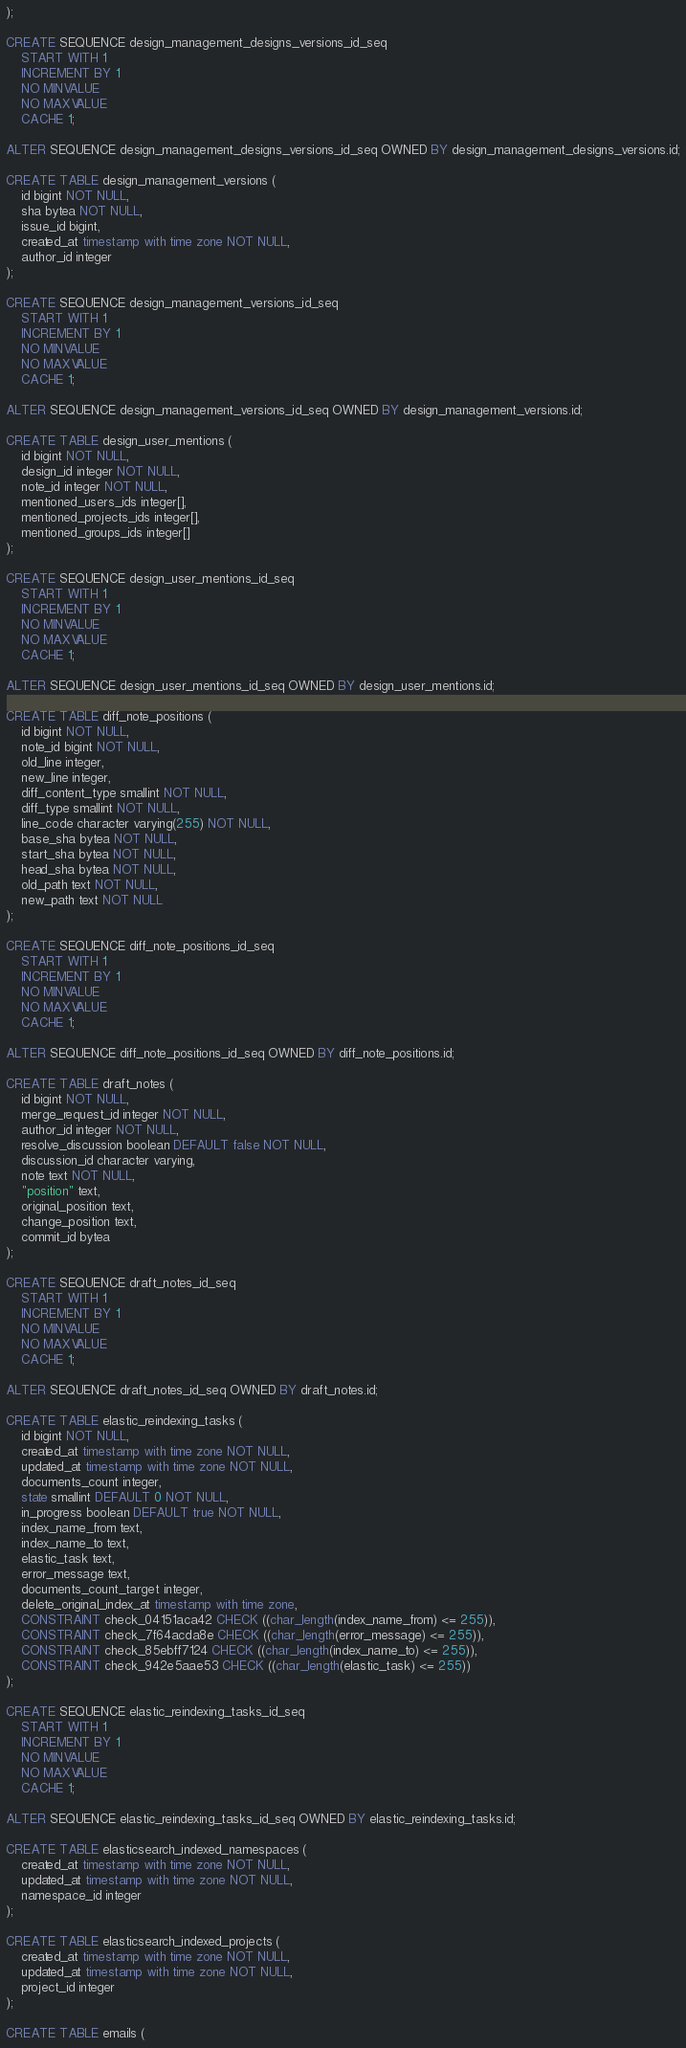Convert code to text. <code><loc_0><loc_0><loc_500><loc_500><_SQL_>);

CREATE SEQUENCE design_management_designs_versions_id_seq
    START WITH 1
    INCREMENT BY 1
    NO MINVALUE
    NO MAXVALUE
    CACHE 1;

ALTER SEQUENCE design_management_designs_versions_id_seq OWNED BY design_management_designs_versions.id;

CREATE TABLE design_management_versions (
    id bigint NOT NULL,
    sha bytea NOT NULL,
    issue_id bigint,
    created_at timestamp with time zone NOT NULL,
    author_id integer
);

CREATE SEQUENCE design_management_versions_id_seq
    START WITH 1
    INCREMENT BY 1
    NO MINVALUE
    NO MAXVALUE
    CACHE 1;

ALTER SEQUENCE design_management_versions_id_seq OWNED BY design_management_versions.id;

CREATE TABLE design_user_mentions (
    id bigint NOT NULL,
    design_id integer NOT NULL,
    note_id integer NOT NULL,
    mentioned_users_ids integer[],
    mentioned_projects_ids integer[],
    mentioned_groups_ids integer[]
);

CREATE SEQUENCE design_user_mentions_id_seq
    START WITH 1
    INCREMENT BY 1
    NO MINVALUE
    NO MAXVALUE
    CACHE 1;

ALTER SEQUENCE design_user_mentions_id_seq OWNED BY design_user_mentions.id;

CREATE TABLE diff_note_positions (
    id bigint NOT NULL,
    note_id bigint NOT NULL,
    old_line integer,
    new_line integer,
    diff_content_type smallint NOT NULL,
    diff_type smallint NOT NULL,
    line_code character varying(255) NOT NULL,
    base_sha bytea NOT NULL,
    start_sha bytea NOT NULL,
    head_sha bytea NOT NULL,
    old_path text NOT NULL,
    new_path text NOT NULL
);

CREATE SEQUENCE diff_note_positions_id_seq
    START WITH 1
    INCREMENT BY 1
    NO MINVALUE
    NO MAXVALUE
    CACHE 1;

ALTER SEQUENCE diff_note_positions_id_seq OWNED BY diff_note_positions.id;

CREATE TABLE draft_notes (
    id bigint NOT NULL,
    merge_request_id integer NOT NULL,
    author_id integer NOT NULL,
    resolve_discussion boolean DEFAULT false NOT NULL,
    discussion_id character varying,
    note text NOT NULL,
    "position" text,
    original_position text,
    change_position text,
    commit_id bytea
);

CREATE SEQUENCE draft_notes_id_seq
    START WITH 1
    INCREMENT BY 1
    NO MINVALUE
    NO MAXVALUE
    CACHE 1;

ALTER SEQUENCE draft_notes_id_seq OWNED BY draft_notes.id;

CREATE TABLE elastic_reindexing_tasks (
    id bigint NOT NULL,
    created_at timestamp with time zone NOT NULL,
    updated_at timestamp with time zone NOT NULL,
    documents_count integer,
    state smallint DEFAULT 0 NOT NULL,
    in_progress boolean DEFAULT true NOT NULL,
    index_name_from text,
    index_name_to text,
    elastic_task text,
    error_message text,
    documents_count_target integer,
    delete_original_index_at timestamp with time zone,
    CONSTRAINT check_04151aca42 CHECK ((char_length(index_name_from) <= 255)),
    CONSTRAINT check_7f64acda8e CHECK ((char_length(error_message) <= 255)),
    CONSTRAINT check_85ebff7124 CHECK ((char_length(index_name_to) <= 255)),
    CONSTRAINT check_942e5aae53 CHECK ((char_length(elastic_task) <= 255))
);

CREATE SEQUENCE elastic_reindexing_tasks_id_seq
    START WITH 1
    INCREMENT BY 1
    NO MINVALUE
    NO MAXVALUE
    CACHE 1;

ALTER SEQUENCE elastic_reindexing_tasks_id_seq OWNED BY elastic_reindexing_tasks.id;

CREATE TABLE elasticsearch_indexed_namespaces (
    created_at timestamp with time zone NOT NULL,
    updated_at timestamp with time zone NOT NULL,
    namespace_id integer
);

CREATE TABLE elasticsearch_indexed_projects (
    created_at timestamp with time zone NOT NULL,
    updated_at timestamp with time zone NOT NULL,
    project_id integer
);

CREATE TABLE emails (</code> 